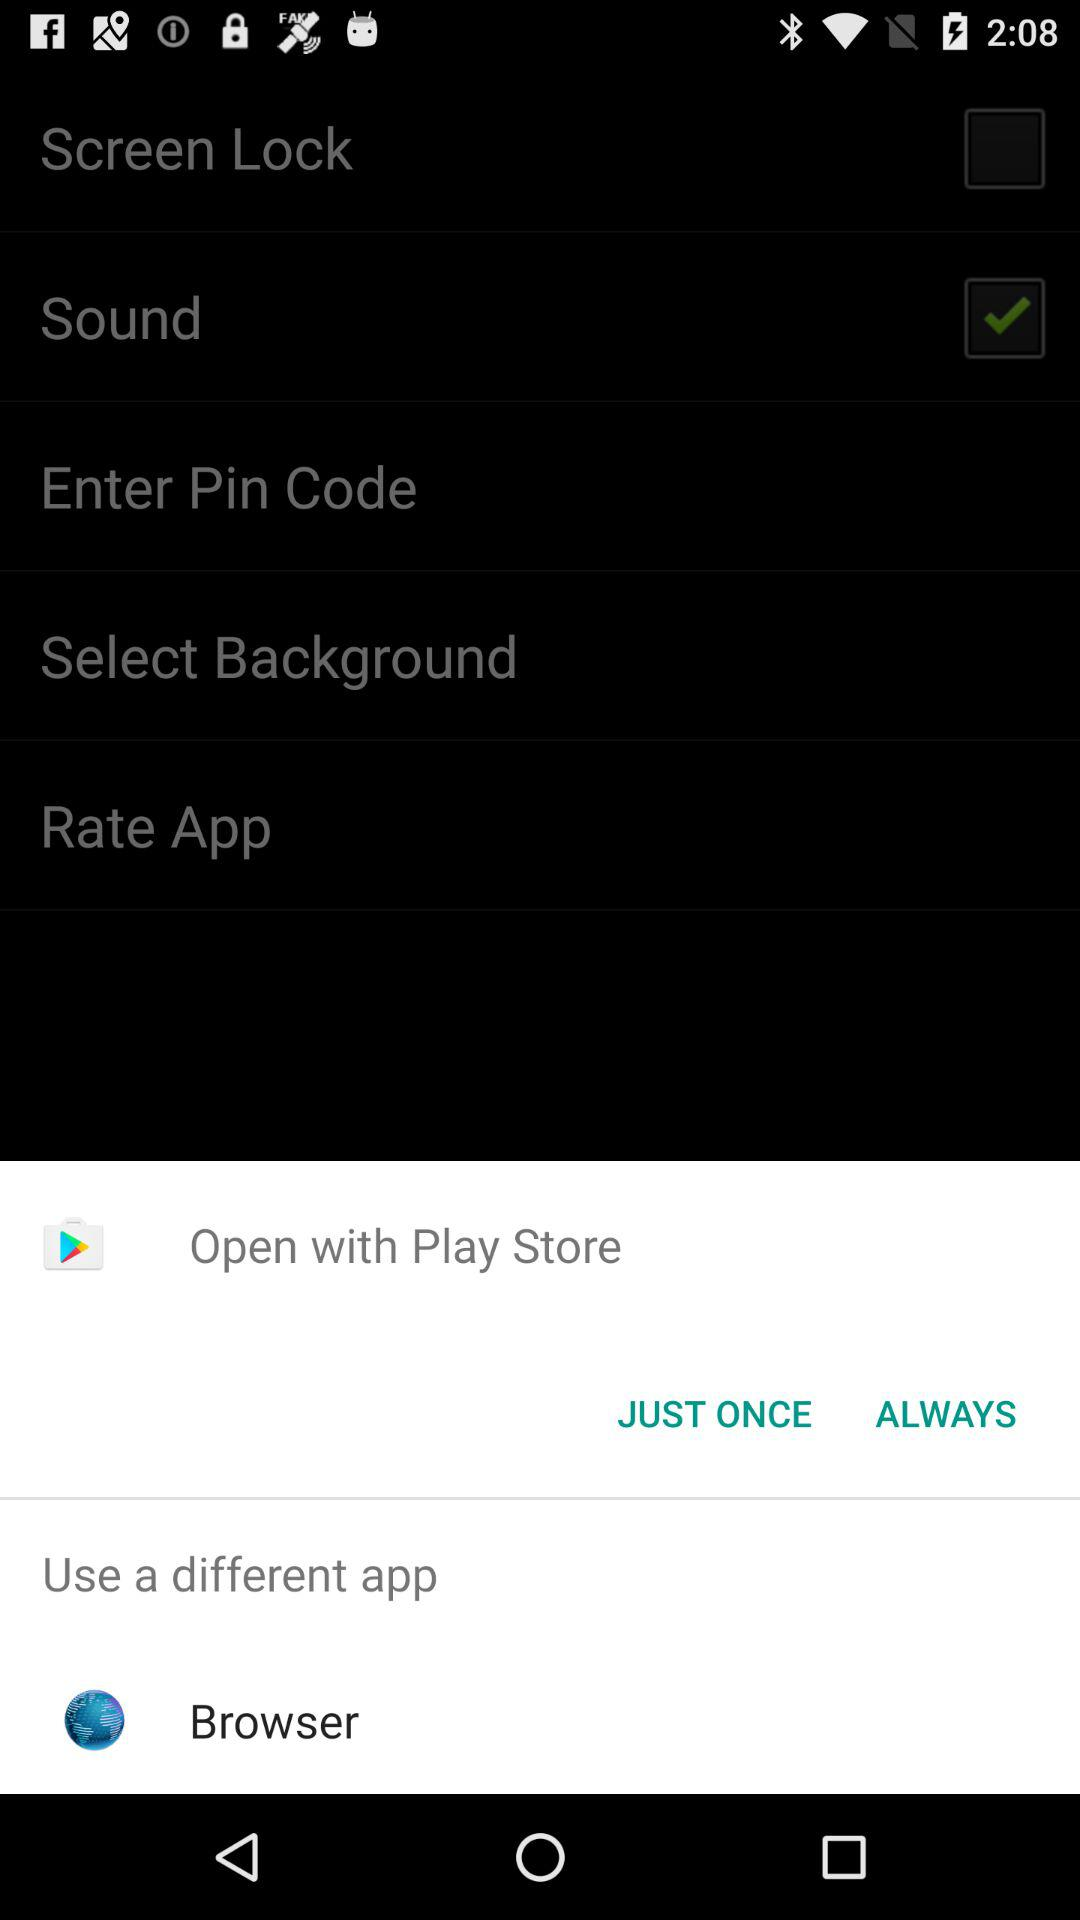What is the status of "Sound"? The status is "on". 